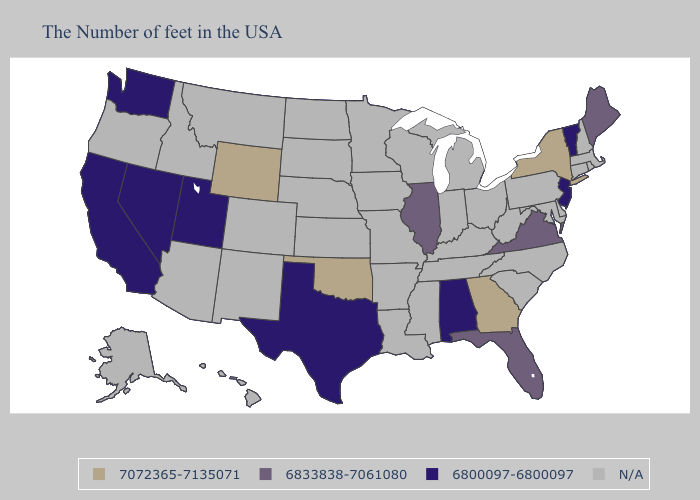Name the states that have a value in the range 6833838-7061080?
Give a very brief answer. Maine, Virginia, Florida, Illinois. Does Oklahoma have the highest value in the USA?
Write a very short answer. Yes. What is the lowest value in the West?
Keep it brief. 6800097-6800097. What is the lowest value in the USA?
Keep it brief. 6800097-6800097. What is the lowest value in the West?
Short answer required. 6800097-6800097. Does New York have the highest value in the Northeast?
Give a very brief answer. Yes. Name the states that have a value in the range 6800097-6800097?
Give a very brief answer. Vermont, New Jersey, Alabama, Texas, Utah, Nevada, California, Washington. Name the states that have a value in the range N/A?
Answer briefly. Massachusetts, Rhode Island, New Hampshire, Connecticut, Delaware, Maryland, Pennsylvania, North Carolina, South Carolina, West Virginia, Ohio, Michigan, Kentucky, Indiana, Tennessee, Wisconsin, Mississippi, Louisiana, Missouri, Arkansas, Minnesota, Iowa, Kansas, Nebraska, South Dakota, North Dakota, Colorado, New Mexico, Montana, Arizona, Idaho, Oregon, Alaska, Hawaii. Name the states that have a value in the range N/A?
Answer briefly. Massachusetts, Rhode Island, New Hampshire, Connecticut, Delaware, Maryland, Pennsylvania, North Carolina, South Carolina, West Virginia, Ohio, Michigan, Kentucky, Indiana, Tennessee, Wisconsin, Mississippi, Louisiana, Missouri, Arkansas, Minnesota, Iowa, Kansas, Nebraska, South Dakota, North Dakota, Colorado, New Mexico, Montana, Arizona, Idaho, Oregon, Alaska, Hawaii. Does Wyoming have the lowest value in the West?
Answer briefly. No. 